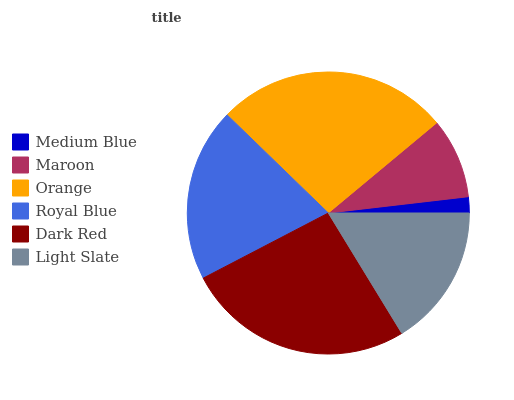Is Medium Blue the minimum?
Answer yes or no. Yes. Is Orange the maximum?
Answer yes or no. Yes. Is Maroon the minimum?
Answer yes or no. No. Is Maroon the maximum?
Answer yes or no. No. Is Maroon greater than Medium Blue?
Answer yes or no. Yes. Is Medium Blue less than Maroon?
Answer yes or no. Yes. Is Medium Blue greater than Maroon?
Answer yes or no. No. Is Maroon less than Medium Blue?
Answer yes or no. No. Is Royal Blue the high median?
Answer yes or no. Yes. Is Light Slate the low median?
Answer yes or no. Yes. Is Dark Red the high median?
Answer yes or no. No. Is Royal Blue the low median?
Answer yes or no. No. 